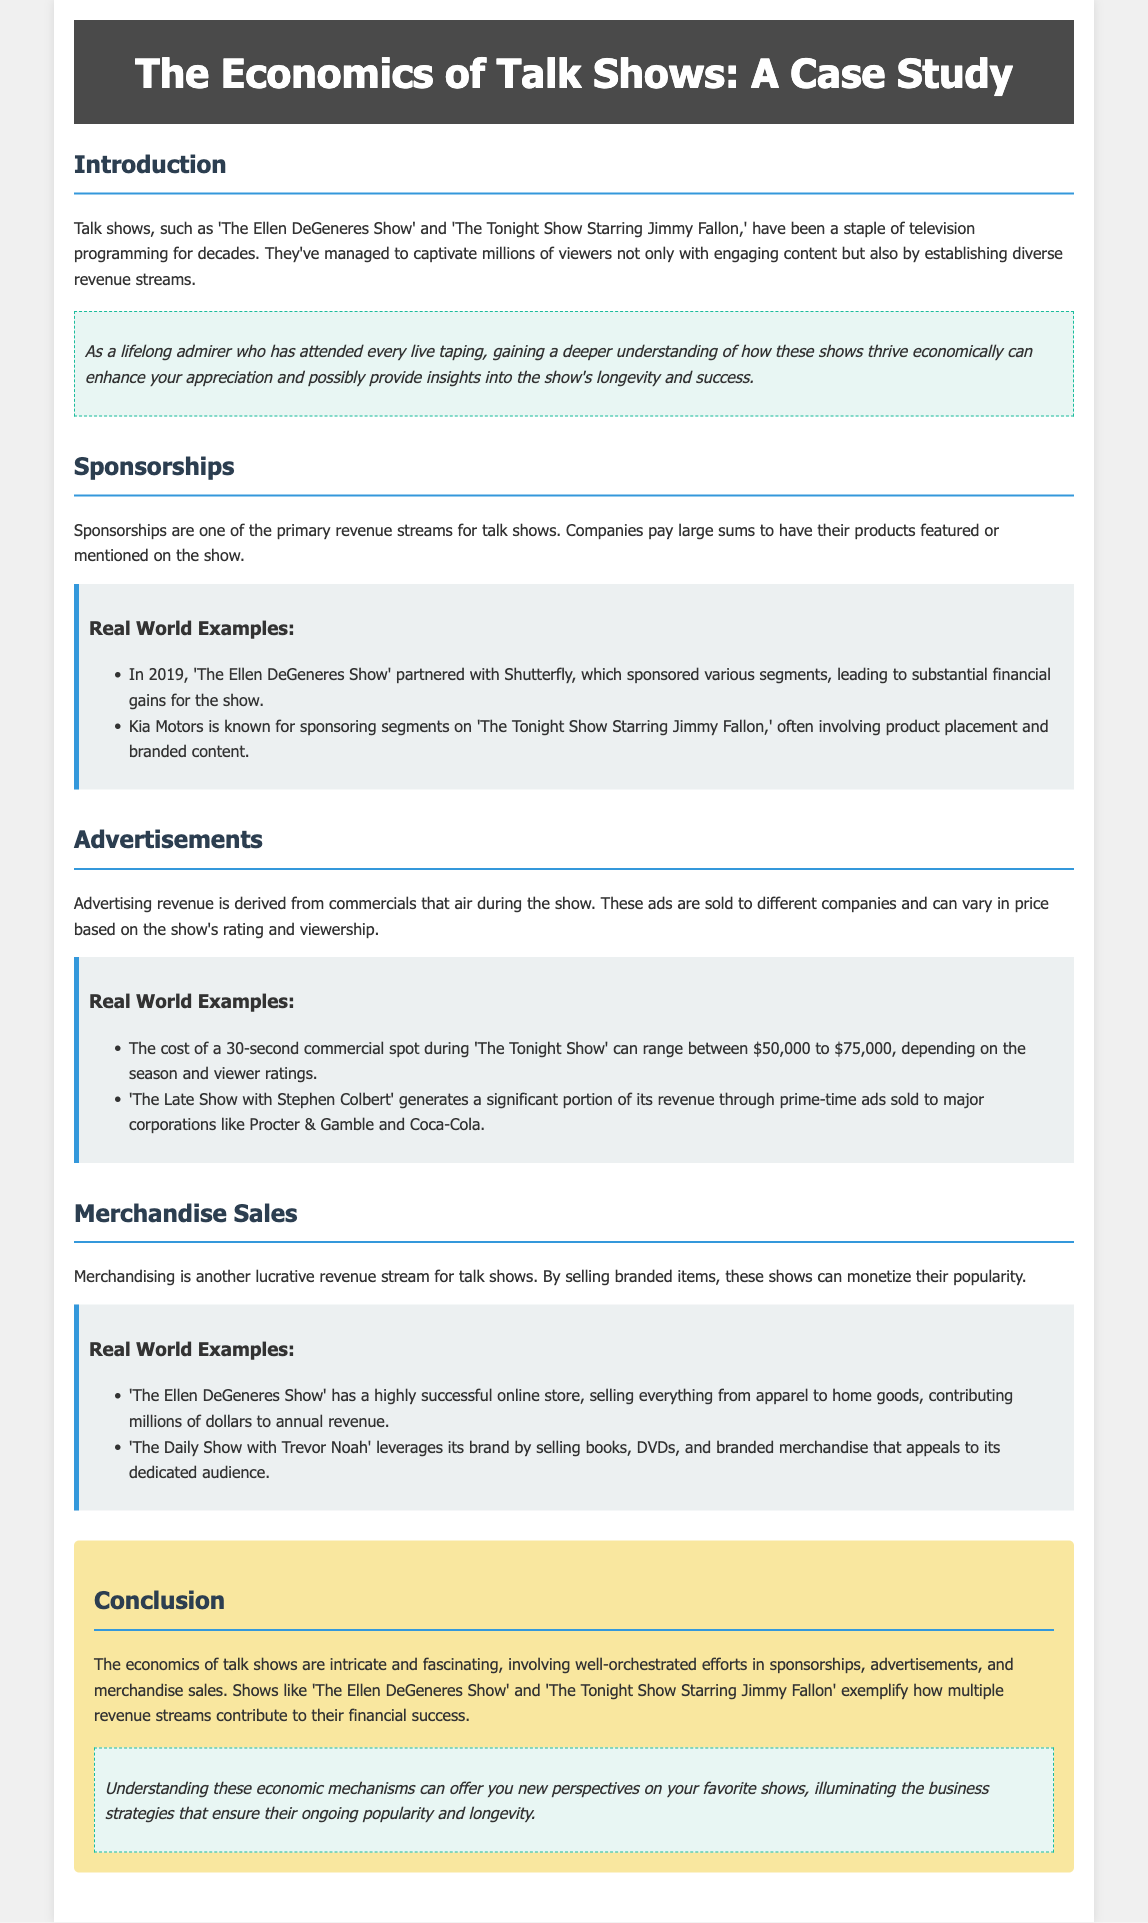What revenue streams are discussed in the document? The document discusses sponsorships, advertisements, and merchandise sales as revenue streams for talk shows.
Answer: sponsorships, advertisements, merchandise sales Which show partnered with Shutterfly in 2019? The example provided in the document mentions that 'The Ellen DeGeneres Show' partnered with Shutterfly in 2019.
Answer: The Ellen DeGeneres Show How much can a 30-second commercial cost during 'The Tonight Show'? According to the document, the cost of a 30-second commercial spot during 'The Tonight Show' can range between $50,000 to $75,000.
Answer: $50,000 to $75,000 What type of items does 'The Ellen DeGeneres Show' sell in its online store? The document specifies that 'The Ellen DeGeneres Show' sells everything from apparel to home goods in its online store.
Answer: apparel to home goods What percentage of revenue does 'The Late Show with Stephen Colbert' generate from ads? The document states that 'The Late Show with Stephen Colbert' generates a significant portion of its revenue through prime-time ads.
Answer: significant portion What does the conclusion suggest about the economics of talk shows? The conclusion highlights that the economics of talk shows are intricate and involve various revenue streams, emphasizing their financial success.
Answer: intricate and involve various revenue streams Which show leverages its brand to sell books and DVDs? The document mentions that 'The Daily Show with Trevor Noah' leverages its brand to sell books, DVDs, and branded merchandise.
Answer: The Daily Show with Trevor Noah 